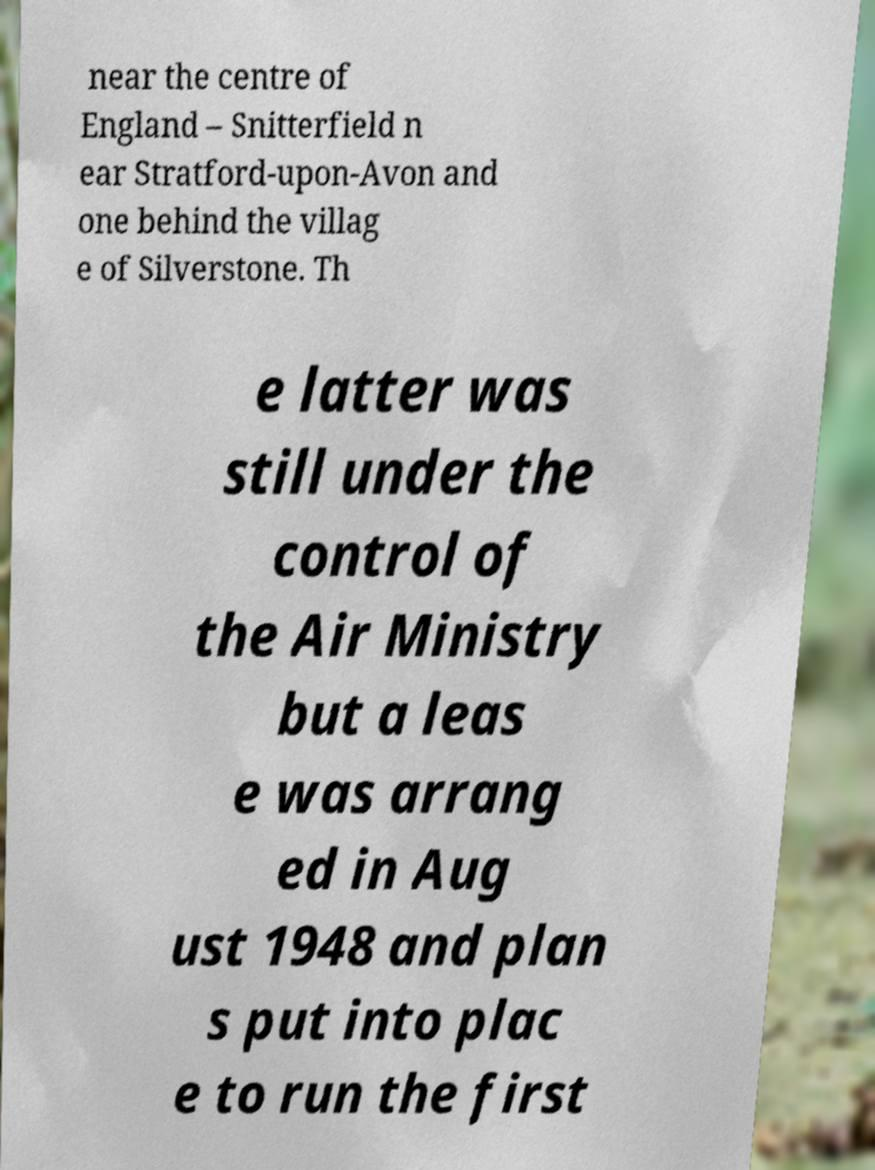Could you assist in decoding the text presented in this image and type it out clearly? near the centre of England – Snitterfield n ear Stratford-upon-Avon and one behind the villag e of Silverstone. Th e latter was still under the control of the Air Ministry but a leas e was arrang ed in Aug ust 1948 and plan s put into plac e to run the first 